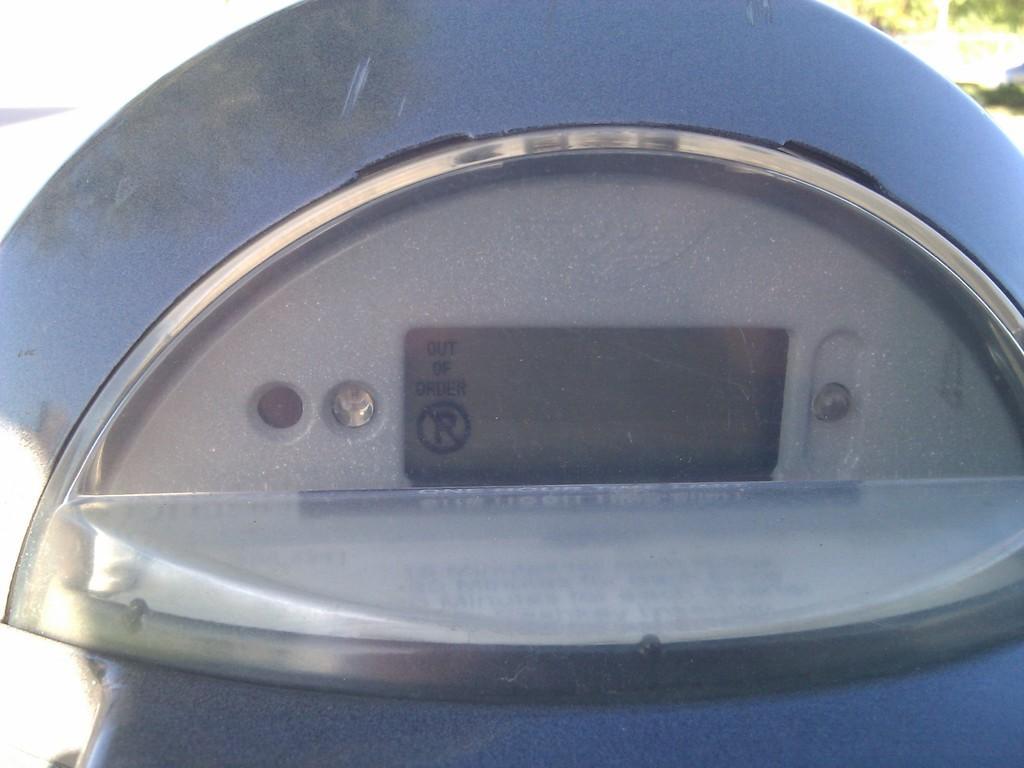Can you describe this image briefly? In this picture we can see a parking ticket meter display. 